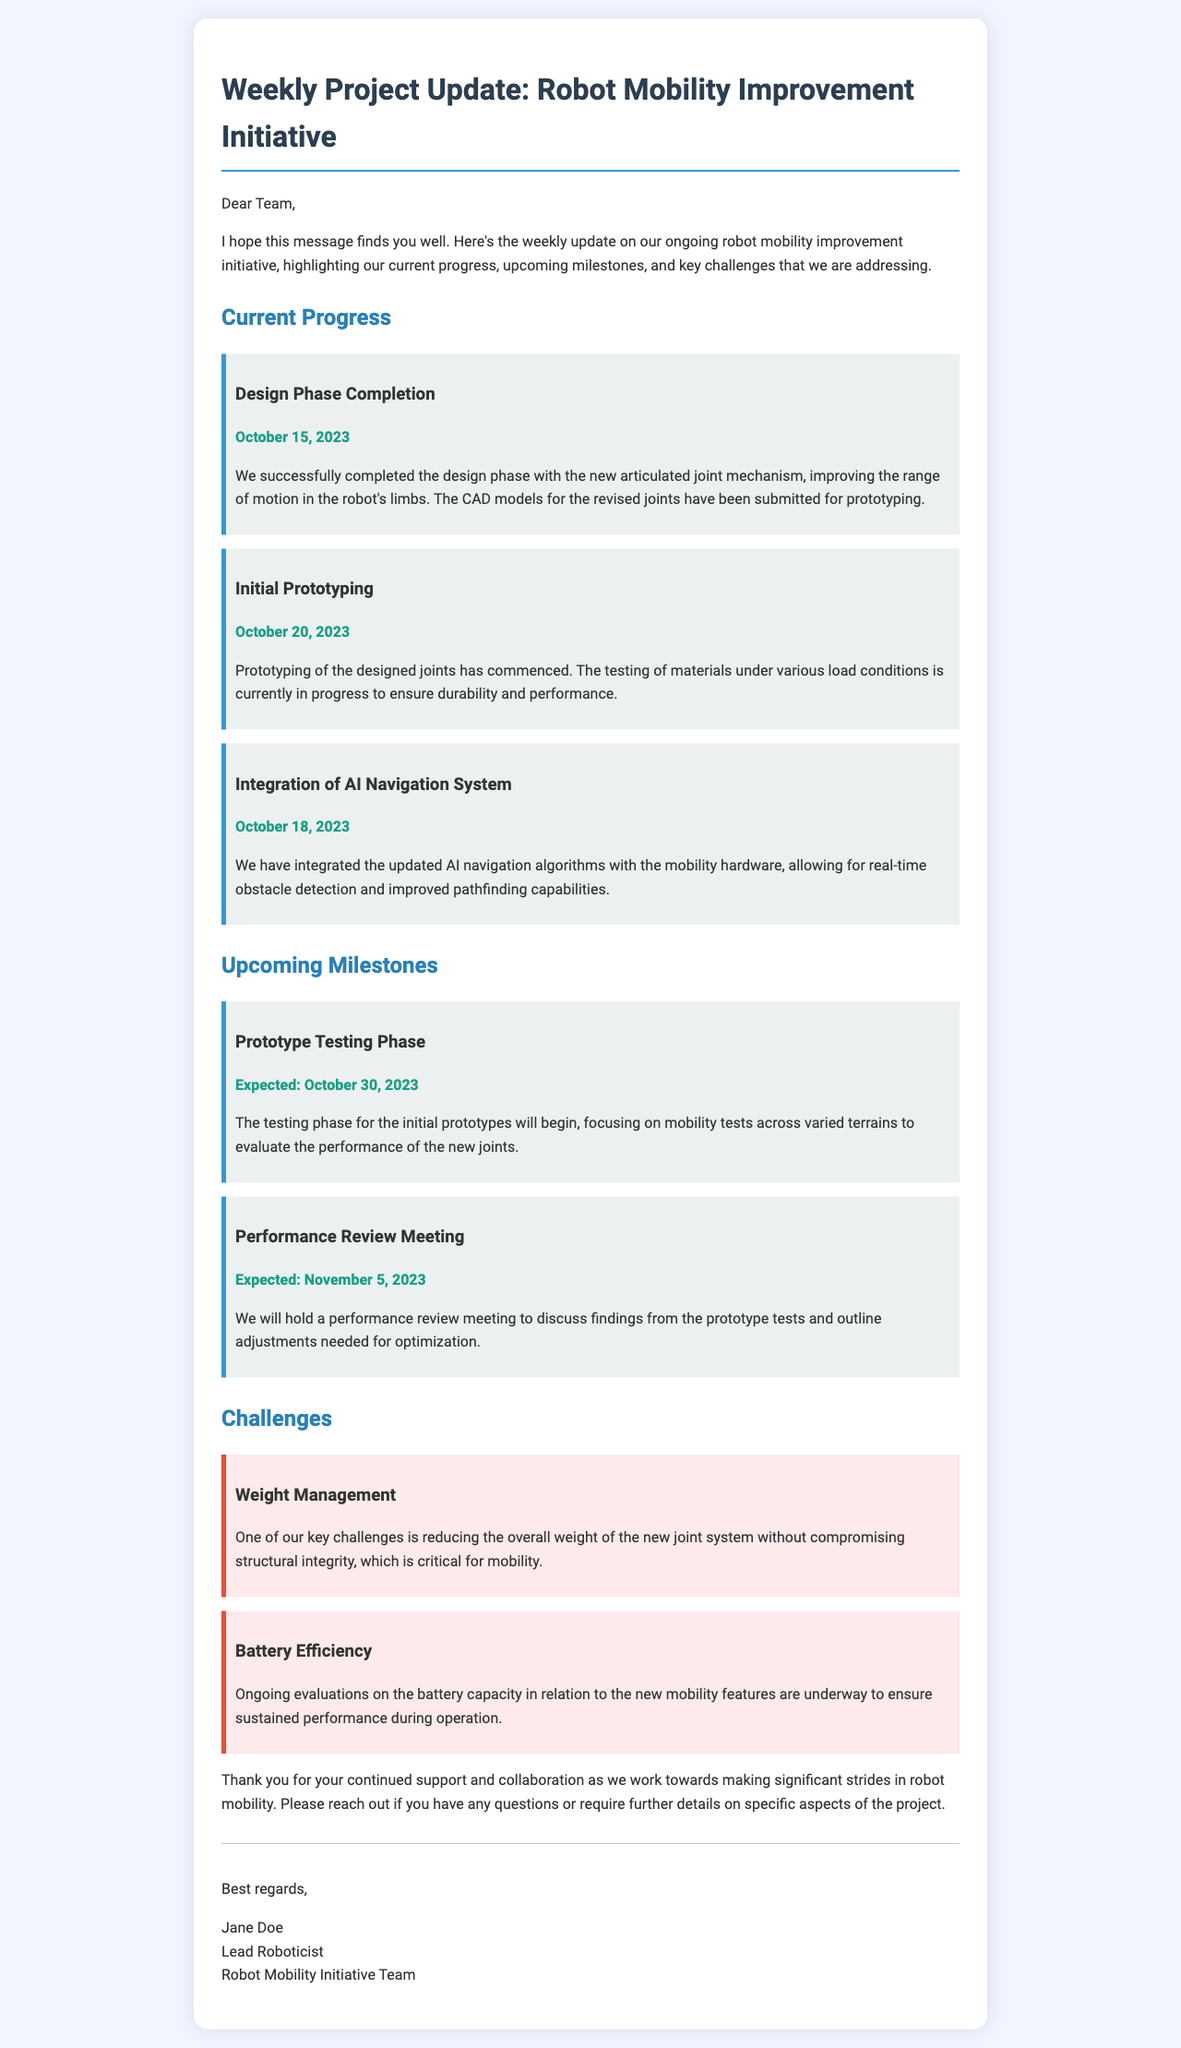What is the date of design phase completion? The design phase completion date is mentioned in the document as October 15, 2023.
Answer: October 15, 2023 What is the expected start date for the prototype testing phase? The document states that the prototype testing phase is expected to begin on October 30, 2023.
Answer: October 30, 2023 Who is the lead roboticist? The email concludes with the signature of the lead roboticist, Jane Doe.
Answer: Jane Doe What is a key challenge mentioned in the update? The document lists "Weight Management" as one of the key challenges the team is facing.
Answer: Weight Management What milestone is set for November 5, 2023? The document mentions a "Performance Review Meeting" scheduled for November 5, 2023.
Answer: Performance Review Meeting How many milestones are listed under current progress? The document outlines three milestones under current progress: design phase completion, initial prototyping, and integration of AI navigation system.
Answer: Three What aspect of mobility does the AI navigation system improve? The integration of the AI navigation system allows for real-time obstacle detection and improved pathfinding capabilities.
Answer: Obstacle detection and pathfinding What is the purpose of the performance review meeting? The purpose of the performance review meeting is to discuss findings from the prototype tests and outline adjustments needed for optimization.
Answer: Discuss findings and outline adjustments 